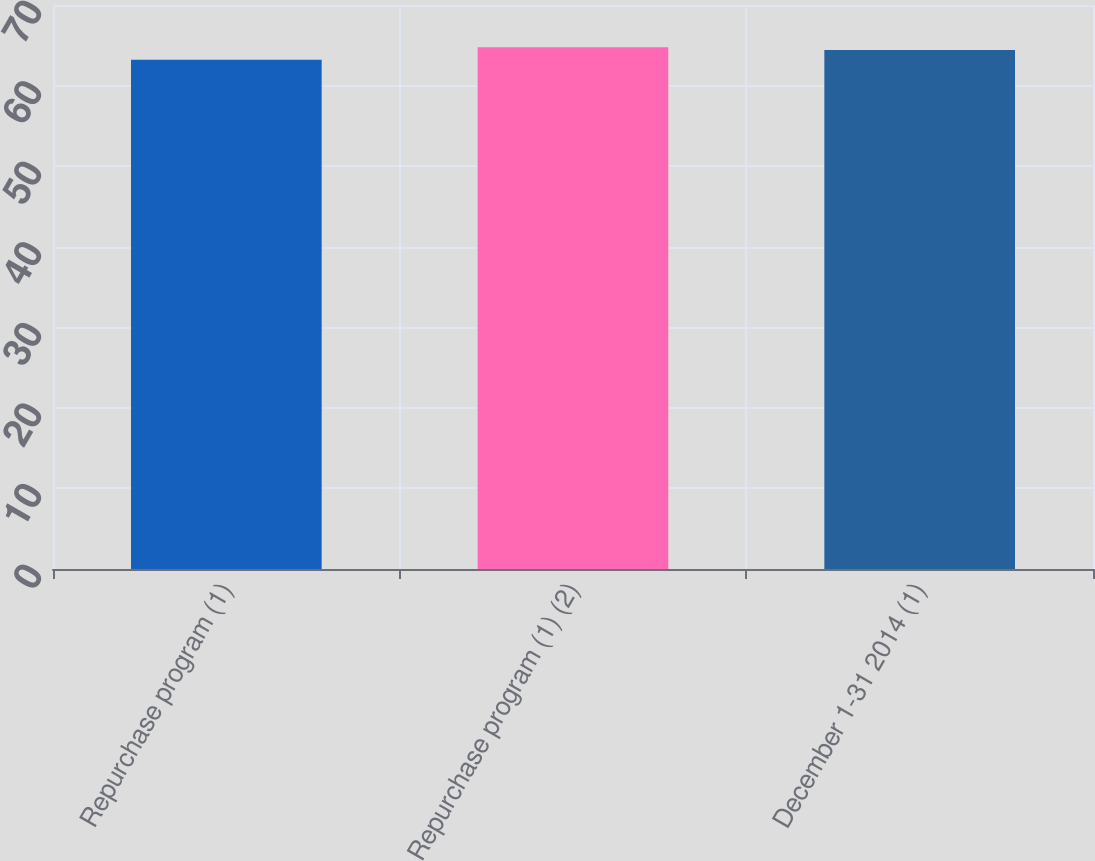Convert chart. <chart><loc_0><loc_0><loc_500><loc_500><bar_chart><fcel>Repurchase program (1)<fcel>Repurchase program (1) (2)<fcel>December 1-31 2014 (1)<nl><fcel>63.22<fcel>64.76<fcel>64.43<nl></chart> 